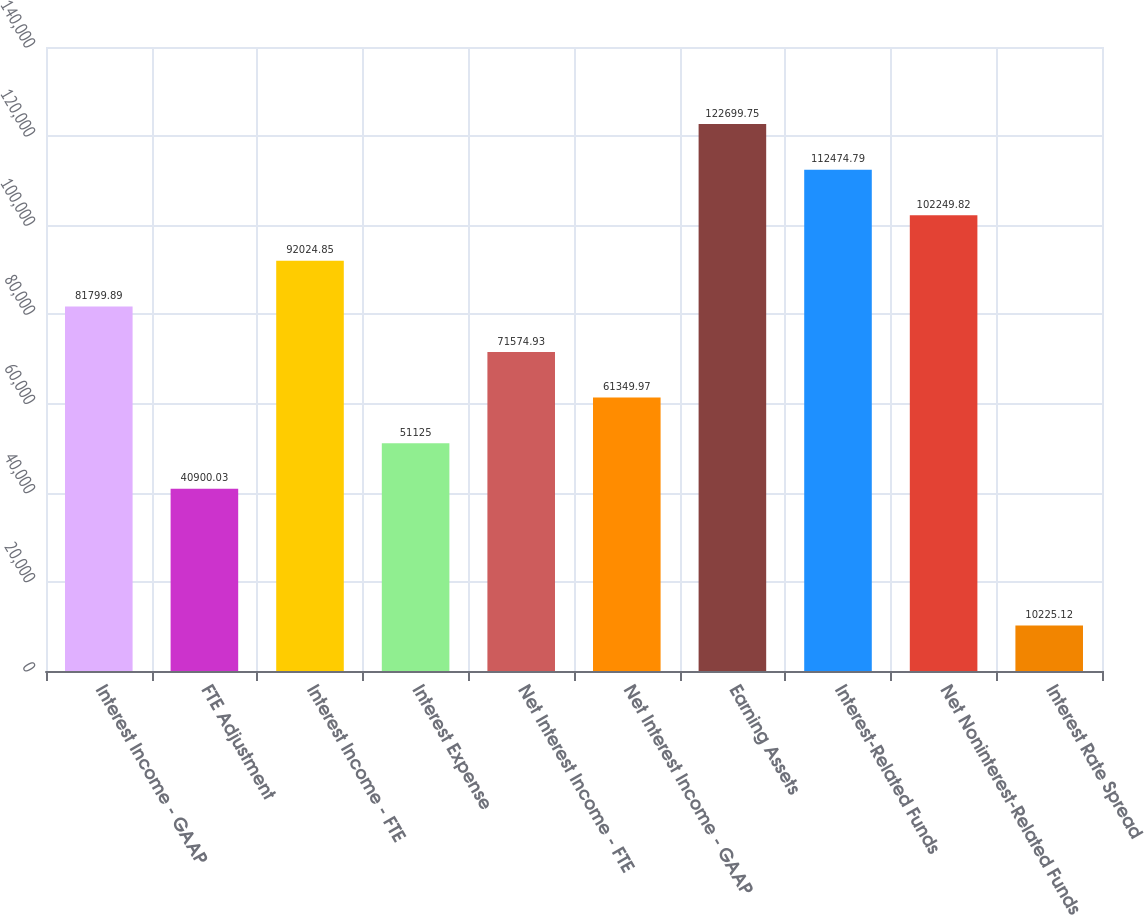<chart> <loc_0><loc_0><loc_500><loc_500><bar_chart><fcel>Interest Income - GAAP<fcel>FTE Adjustment<fcel>Interest Income - FTE<fcel>Interest Expense<fcel>Net Interest Income - FTE<fcel>Net Interest Income - GAAP<fcel>Earning Assets<fcel>Interest-Related Funds<fcel>Net Noninterest-Related Funds<fcel>Interest Rate Spread<nl><fcel>81799.9<fcel>40900<fcel>92024.9<fcel>51125<fcel>71574.9<fcel>61350<fcel>122700<fcel>112475<fcel>102250<fcel>10225.1<nl></chart> 